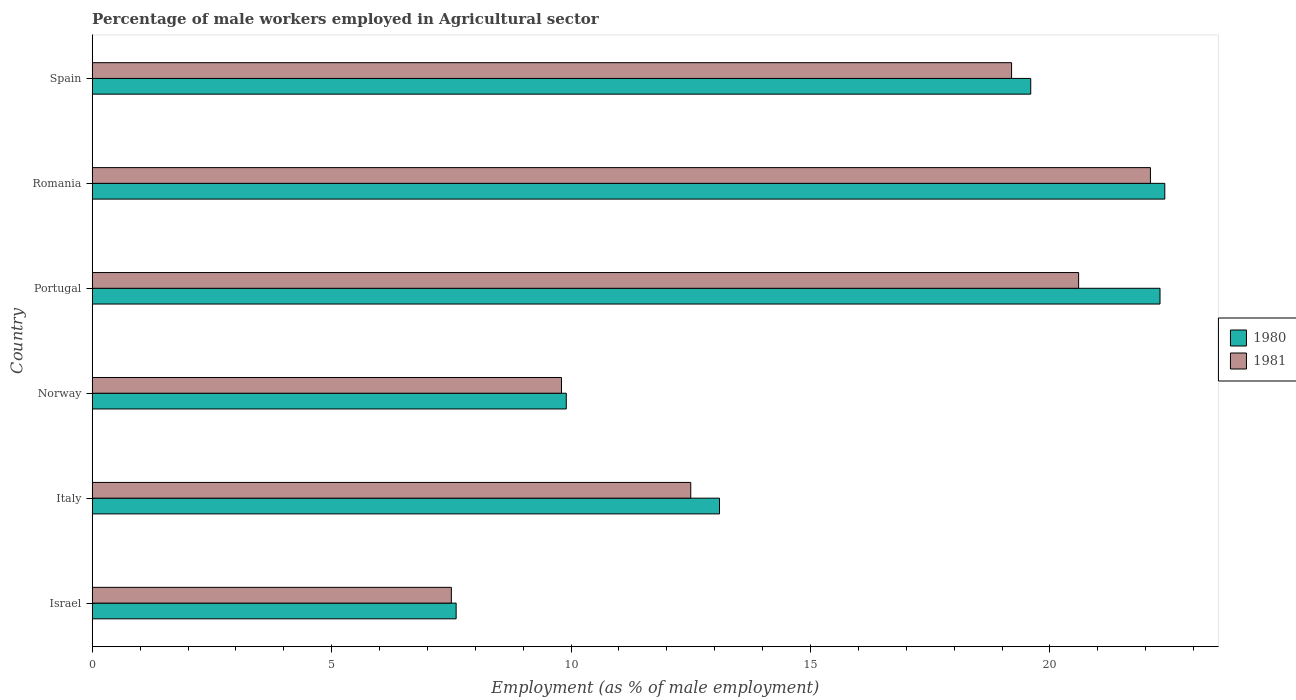How many different coloured bars are there?
Provide a succinct answer. 2. How many groups of bars are there?
Offer a terse response. 6. What is the label of the 1st group of bars from the top?
Offer a terse response. Spain. In how many cases, is the number of bars for a given country not equal to the number of legend labels?
Your answer should be very brief. 0. What is the percentage of male workers employed in Agricultural sector in 1980 in Spain?
Make the answer very short. 19.6. Across all countries, what is the maximum percentage of male workers employed in Agricultural sector in 1980?
Your answer should be compact. 22.4. Across all countries, what is the minimum percentage of male workers employed in Agricultural sector in 1981?
Make the answer very short. 7.5. In which country was the percentage of male workers employed in Agricultural sector in 1980 maximum?
Provide a short and direct response. Romania. In which country was the percentage of male workers employed in Agricultural sector in 1981 minimum?
Keep it short and to the point. Israel. What is the total percentage of male workers employed in Agricultural sector in 1981 in the graph?
Provide a short and direct response. 91.7. What is the difference between the percentage of male workers employed in Agricultural sector in 1981 in Italy and that in Portugal?
Make the answer very short. -8.1. What is the difference between the percentage of male workers employed in Agricultural sector in 1981 in Portugal and the percentage of male workers employed in Agricultural sector in 1980 in Norway?
Give a very brief answer. 10.7. What is the average percentage of male workers employed in Agricultural sector in 1981 per country?
Your answer should be very brief. 15.28. What is the difference between the percentage of male workers employed in Agricultural sector in 1981 and percentage of male workers employed in Agricultural sector in 1980 in Portugal?
Give a very brief answer. -1.7. In how many countries, is the percentage of male workers employed in Agricultural sector in 1981 greater than 11 %?
Offer a terse response. 4. What is the ratio of the percentage of male workers employed in Agricultural sector in 1981 in Norway to that in Portugal?
Offer a very short reply. 0.48. Is the percentage of male workers employed in Agricultural sector in 1980 in Norway less than that in Portugal?
Ensure brevity in your answer.  Yes. Is the difference between the percentage of male workers employed in Agricultural sector in 1981 in Norway and Spain greater than the difference between the percentage of male workers employed in Agricultural sector in 1980 in Norway and Spain?
Give a very brief answer. Yes. What is the difference between the highest and the second highest percentage of male workers employed in Agricultural sector in 1981?
Provide a short and direct response. 1.5. What is the difference between the highest and the lowest percentage of male workers employed in Agricultural sector in 1981?
Keep it short and to the point. 14.6. In how many countries, is the percentage of male workers employed in Agricultural sector in 1981 greater than the average percentage of male workers employed in Agricultural sector in 1981 taken over all countries?
Provide a succinct answer. 3. How many bars are there?
Provide a short and direct response. 12. Where does the legend appear in the graph?
Provide a short and direct response. Center right. How many legend labels are there?
Make the answer very short. 2. How are the legend labels stacked?
Offer a terse response. Vertical. What is the title of the graph?
Offer a very short reply. Percentage of male workers employed in Agricultural sector. What is the label or title of the X-axis?
Provide a short and direct response. Employment (as % of male employment). What is the label or title of the Y-axis?
Provide a succinct answer. Country. What is the Employment (as % of male employment) in 1980 in Israel?
Keep it short and to the point. 7.6. What is the Employment (as % of male employment) of 1980 in Italy?
Offer a terse response. 13.1. What is the Employment (as % of male employment) in 1981 in Italy?
Your response must be concise. 12.5. What is the Employment (as % of male employment) in 1980 in Norway?
Your answer should be very brief. 9.9. What is the Employment (as % of male employment) of 1981 in Norway?
Ensure brevity in your answer.  9.8. What is the Employment (as % of male employment) in 1980 in Portugal?
Your answer should be very brief. 22.3. What is the Employment (as % of male employment) of 1981 in Portugal?
Offer a terse response. 20.6. What is the Employment (as % of male employment) in 1980 in Romania?
Provide a short and direct response. 22.4. What is the Employment (as % of male employment) in 1981 in Romania?
Your answer should be compact. 22.1. What is the Employment (as % of male employment) in 1980 in Spain?
Give a very brief answer. 19.6. What is the Employment (as % of male employment) in 1981 in Spain?
Your response must be concise. 19.2. Across all countries, what is the maximum Employment (as % of male employment) of 1980?
Offer a terse response. 22.4. Across all countries, what is the maximum Employment (as % of male employment) in 1981?
Your answer should be very brief. 22.1. Across all countries, what is the minimum Employment (as % of male employment) of 1980?
Your answer should be very brief. 7.6. Across all countries, what is the minimum Employment (as % of male employment) in 1981?
Provide a succinct answer. 7.5. What is the total Employment (as % of male employment) in 1980 in the graph?
Provide a succinct answer. 94.9. What is the total Employment (as % of male employment) in 1981 in the graph?
Your answer should be compact. 91.7. What is the difference between the Employment (as % of male employment) of 1981 in Israel and that in Italy?
Provide a succinct answer. -5. What is the difference between the Employment (as % of male employment) in 1980 in Israel and that in Portugal?
Provide a succinct answer. -14.7. What is the difference between the Employment (as % of male employment) in 1980 in Israel and that in Romania?
Ensure brevity in your answer.  -14.8. What is the difference between the Employment (as % of male employment) in 1981 in Israel and that in Romania?
Provide a succinct answer. -14.6. What is the difference between the Employment (as % of male employment) of 1981 in Israel and that in Spain?
Your answer should be compact. -11.7. What is the difference between the Employment (as % of male employment) in 1980 in Italy and that in Norway?
Your answer should be compact. 3.2. What is the difference between the Employment (as % of male employment) in 1980 in Italy and that in Portugal?
Offer a terse response. -9.2. What is the difference between the Employment (as % of male employment) of 1981 in Italy and that in Portugal?
Provide a short and direct response. -8.1. What is the difference between the Employment (as % of male employment) in 1981 in Italy and that in Spain?
Keep it short and to the point. -6.7. What is the difference between the Employment (as % of male employment) in 1981 in Norway and that in Portugal?
Provide a short and direct response. -10.8. What is the difference between the Employment (as % of male employment) of 1980 in Norway and that in Romania?
Keep it short and to the point. -12.5. What is the difference between the Employment (as % of male employment) in 1981 in Norway and that in Romania?
Your answer should be compact. -12.3. What is the difference between the Employment (as % of male employment) of 1981 in Portugal and that in Romania?
Your answer should be very brief. -1.5. What is the difference between the Employment (as % of male employment) in 1980 in Romania and that in Spain?
Your answer should be very brief. 2.8. What is the difference between the Employment (as % of male employment) in 1981 in Romania and that in Spain?
Your answer should be compact. 2.9. What is the difference between the Employment (as % of male employment) in 1980 in Israel and the Employment (as % of male employment) in 1981 in Italy?
Make the answer very short. -4.9. What is the difference between the Employment (as % of male employment) in 1980 in Israel and the Employment (as % of male employment) in 1981 in Norway?
Keep it short and to the point. -2.2. What is the difference between the Employment (as % of male employment) of 1980 in Israel and the Employment (as % of male employment) of 1981 in Portugal?
Your response must be concise. -13. What is the difference between the Employment (as % of male employment) of 1980 in Israel and the Employment (as % of male employment) of 1981 in Spain?
Provide a succinct answer. -11.6. What is the difference between the Employment (as % of male employment) of 1980 in Italy and the Employment (as % of male employment) of 1981 in Norway?
Keep it short and to the point. 3.3. What is the difference between the Employment (as % of male employment) in 1980 in Italy and the Employment (as % of male employment) in 1981 in Portugal?
Your answer should be compact. -7.5. What is the difference between the Employment (as % of male employment) of 1980 in Italy and the Employment (as % of male employment) of 1981 in Romania?
Offer a very short reply. -9. What is the difference between the Employment (as % of male employment) in 1980 in Italy and the Employment (as % of male employment) in 1981 in Spain?
Your answer should be compact. -6.1. What is the difference between the Employment (as % of male employment) in 1980 in Norway and the Employment (as % of male employment) in 1981 in Portugal?
Ensure brevity in your answer.  -10.7. What is the difference between the Employment (as % of male employment) in 1980 in Norway and the Employment (as % of male employment) in 1981 in Romania?
Your response must be concise. -12.2. What is the average Employment (as % of male employment) of 1980 per country?
Give a very brief answer. 15.82. What is the average Employment (as % of male employment) of 1981 per country?
Provide a succinct answer. 15.28. What is the difference between the Employment (as % of male employment) of 1980 and Employment (as % of male employment) of 1981 in Israel?
Give a very brief answer. 0.1. What is the difference between the Employment (as % of male employment) in 1980 and Employment (as % of male employment) in 1981 in Italy?
Your answer should be very brief. 0.6. What is the difference between the Employment (as % of male employment) of 1980 and Employment (as % of male employment) of 1981 in Norway?
Provide a succinct answer. 0.1. What is the difference between the Employment (as % of male employment) of 1980 and Employment (as % of male employment) of 1981 in Portugal?
Your response must be concise. 1.7. What is the difference between the Employment (as % of male employment) in 1980 and Employment (as % of male employment) in 1981 in Romania?
Offer a terse response. 0.3. What is the ratio of the Employment (as % of male employment) in 1980 in Israel to that in Italy?
Make the answer very short. 0.58. What is the ratio of the Employment (as % of male employment) in 1981 in Israel to that in Italy?
Make the answer very short. 0.6. What is the ratio of the Employment (as % of male employment) of 1980 in Israel to that in Norway?
Offer a terse response. 0.77. What is the ratio of the Employment (as % of male employment) in 1981 in Israel to that in Norway?
Offer a terse response. 0.77. What is the ratio of the Employment (as % of male employment) in 1980 in Israel to that in Portugal?
Give a very brief answer. 0.34. What is the ratio of the Employment (as % of male employment) in 1981 in Israel to that in Portugal?
Make the answer very short. 0.36. What is the ratio of the Employment (as % of male employment) in 1980 in Israel to that in Romania?
Your answer should be compact. 0.34. What is the ratio of the Employment (as % of male employment) in 1981 in Israel to that in Romania?
Provide a succinct answer. 0.34. What is the ratio of the Employment (as % of male employment) of 1980 in Israel to that in Spain?
Your answer should be compact. 0.39. What is the ratio of the Employment (as % of male employment) in 1981 in Israel to that in Spain?
Your response must be concise. 0.39. What is the ratio of the Employment (as % of male employment) in 1980 in Italy to that in Norway?
Offer a very short reply. 1.32. What is the ratio of the Employment (as % of male employment) in 1981 in Italy to that in Norway?
Keep it short and to the point. 1.28. What is the ratio of the Employment (as % of male employment) of 1980 in Italy to that in Portugal?
Make the answer very short. 0.59. What is the ratio of the Employment (as % of male employment) of 1981 in Italy to that in Portugal?
Give a very brief answer. 0.61. What is the ratio of the Employment (as % of male employment) of 1980 in Italy to that in Romania?
Your answer should be compact. 0.58. What is the ratio of the Employment (as % of male employment) of 1981 in Italy to that in Romania?
Make the answer very short. 0.57. What is the ratio of the Employment (as % of male employment) of 1980 in Italy to that in Spain?
Offer a terse response. 0.67. What is the ratio of the Employment (as % of male employment) in 1981 in Italy to that in Spain?
Keep it short and to the point. 0.65. What is the ratio of the Employment (as % of male employment) in 1980 in Norway to that in Portugal?
Give a very brief answer. 0.44. What is the ratio of the Employment (as % of male employment) of 1981 in Norway to that in Portugal?
Your answer should be compact. 0.48. What is the ratio of the Employment (as % of male employment) of 1980 in Norway to that in Romania?
Provide a succinct answer. 0.44. What is the ratio of the Employment (as % of male employment) of 1981 in Norway to that in Romania?
Offer a very short reply. 0.44. What is the ratio of the Employment (as % of male employment) of 1980 in Norway to that in Spain?
Your answer should be compact. 0.51. What is the ratio of the Employment (as % of male employment) of 1981 in Norway to that in Spain?
Ensure brevity in your answer.  0.51. What is the ratio of the Employment (as % of male employment) of 1980 in Portugal to that in Romania?
Ensure brevity in your answer.  1. What is the ratio of the Employment (as % of male employment) in 1981 in Portugal to that in Romania?
Your response must be concise. 0.93. What is the ratio of the Employment (as % of male employment) in 1980 in Portugal to that in Spain?
Keep it short and to the point. 1.14. What is the ratio of the Employment (as % of male employment) in 1981 in Portugal to that in Spain?
Make the answer very short. 1.07. What is the ratio of the Employment (as % of male employment) of 1981 in Romania to that in Spain?
Your answer should be compact. 1.15. What is the difference between the highest and the second highest Employment (as % of male employment) in 1980?
Provide a succinct answer. 0.1. What is the difference between the highest and the lowest Employment (as % of male employment) in 1981?
Your answer should be very brief. 14.6. 